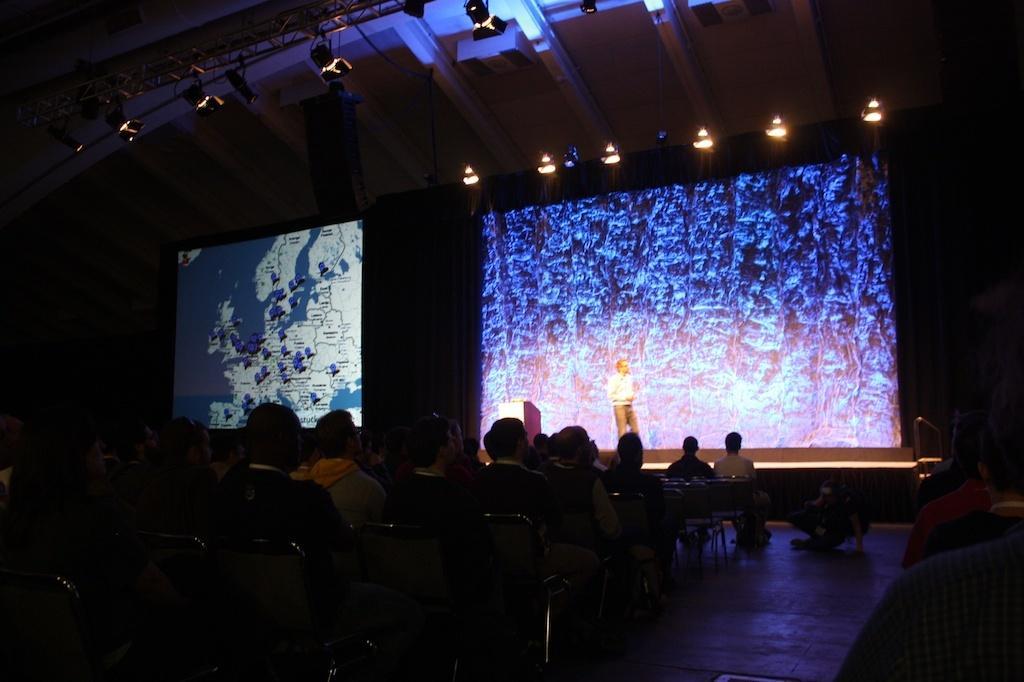In one or two sentences, can you explain what this image depicts? In the center of the image there is a person standing on the dais. At the bottom of the image we can see persons, sitting on the chairs. In the background we can see screens, lights and wall. 